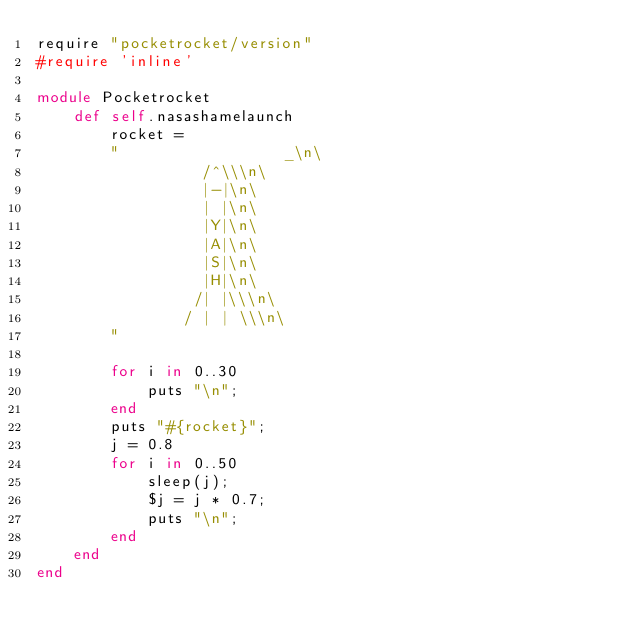<code> <loc_0><loc_0><loc_500><loc_500><_Ruby_>require "pocketrocket/version"
#require 'inline'

module Pocketrocket
	def self.nasashamelaunch
	  	rocket =
		"		   		   _\n\
				  /^\\\n\
				  |-|\n\
				  | |\n\
				  |Y|\n\
				  |A|\n\
				  |S|\n\
				  |H|\n\
				 /| |\\\n\
				/ | | \\\n\
		"

		for i in 0..30
			puts "\n";
		end
		puts "#{rocket}";
		j = 0.8
		for i in 0..50
			sleep(j);
			$j = j * 0.7;
			puts "\n";
		end
	end
end
</code> 